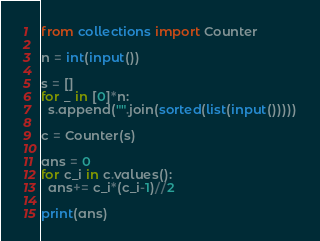<code> <loc_0><loc_0><loc_500><loc_500><_Python_>from collections import Counter

n = int(input())

s = []
for _ in [0]*n:
  s.append("".join(sorted(list(input()))))

c = Counter(s)

ans = 0
for c_i in c.values():
  ans+= c_i*(c_i-1)//2
  
print(ans)</code> 